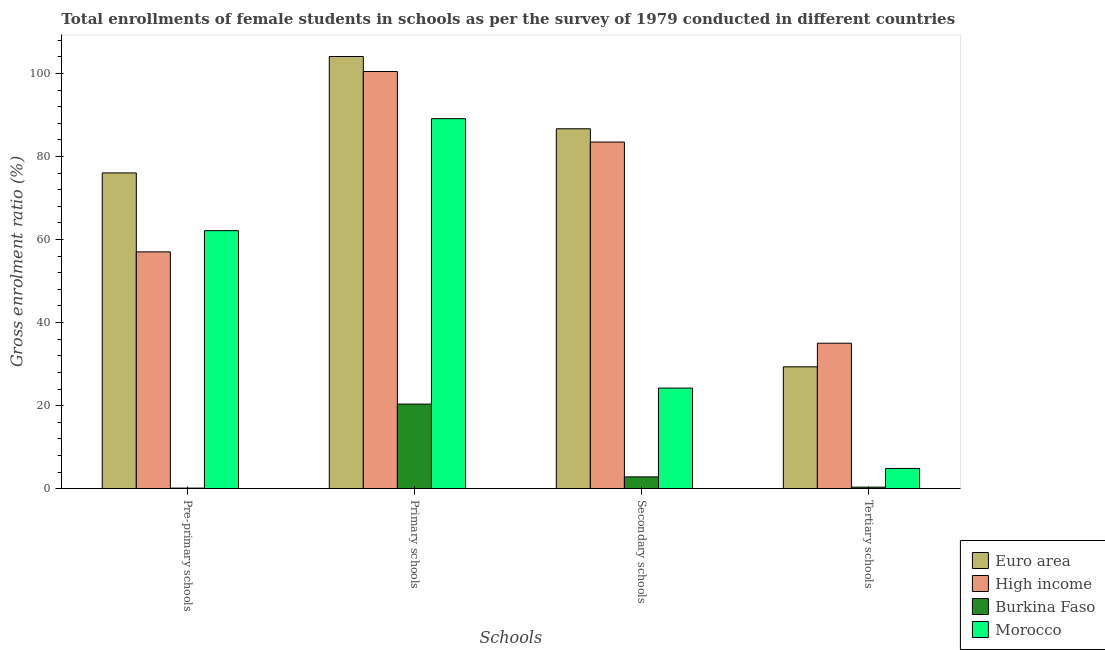How many different coloured bars are there?
Offer a terse response. 4. Are the number of bars per tick equal to the number of legend labels?
Provide a short and direct response. Yes. Are the number of bars on each tick of the X-axis equal?
Your answer should be compact. Yes. How many bars are there on the 4th tick from the left?
Your answer should be compact. 4. How many bars are there on the 1st tick from the right?
Ensure brevity in your answer.  4. What is the label of the 4th group of bars from the left?
Provide a short and direct response. Tertiary schools. What is the gross enrolment ratio(female) in pre-primary schools in Euro area?
Offer a terse response. 76.03. Across all countries, what is the maximum gross enrolment ratio(female) in primary schools?
Your answer should be compact. 104.08. Across all countries, what is the minimum gross enrolment ratio(female) in tertiary schools?
Your answer should be very brief. 0.37. In which country was the gross enrolment ratio(female) in primary schools minimum?
Give a very brief answer. Burkina Faso. What is the total gross enrolment ratio(female) in tertiary schools in the graph?
Your response must be concise. 69.61. What is the difference between the gross enrolment ratio(female) in primary schools in Burkina Faso and that in High income?
Ensure brevity in your answer.  -80.08. What is the difference between the gross enrolment ratio(female) in secondary schools in Morocco and the gross enrolment ratio(female) in tertiary schools in High income?
Your response must be concise. -10.81. What is the average gross enrolment ratio(female) in tertiary schools per country?
Keep it short and to the point. 17.4. What is the difference between the gross enrolment ratio(female) in tertiary schools and gross enrolment ratio(female) in secondary schools in Burkina Faso?
Your response must be concise. -2.47. What is the ratio of the gross enrolment ratio(female) in pre-primary schools in Burkina Faso to that in Morocco?
Keep it short and to the point. 0. Is the difference between the gross enrolment ratio(female) in pre-primary schools in High income and Euro area greater than the difference between the gross enrolment ratio(female) in secondary schools in High income and Euro area?
Make the answer very short. No. What is the difference between the highest and the second highest gross enrolment ratio(female) in tertiary schools?
Your answer should be compact. 5.68. What is the difference between the highest and the lowest gross enrolment ratio(female) in pre-primary schools?
Provide a succinct answer. 75.9. In how many countries, is the gross enrolment ratio(female) in secondary schools greater than the average gross enrolment ratio(female) in secondary schools taken over all countries?
Your answer should be very brief. 2. Is the sum of the gross enrolment ratio(female) in secondary schools in Burkina Faso and High income greater than the maximum gross enrolment ratio(female) in pre-primary schools across all countries?
Your answer should be very brief. Yes. Is it the case that in every country, the sum of the gross enrolment ratio(female) in tertiary schools and gross enrolment ratio(female) in pre-primary schools is greater than the sum of gross enrolment ratio(female) in primary schools and gross enrolment ratio(female) in secondary schools?
Your response must be concise. No. What does the 1st bar from the left in Tertiary schools represents?
Provide a succinct answer. Euro area. What does the 2nd bar from the right in Secondary schools represents?
Your answer should be very brief. Burkina Faso. How many bars are there?
Keep it short and to the point. 16. Are all the bars in the graph horizontal?
Ensure brevity in your answer.  No. How many countries are there in the graph?
Provide a short and direct response. 4. What is the difference between two consecutive major ticks on the Y-axis?
Your answer should be compact. 20. Does the graph contain any zero values?
Offer a terse response. No. Does the graph contain grids?
Your response must be concise. No. Where does the legend appear in the graph?
Offer a terse response. Bottom right. How many legend labels are there?
Provide a short and direct response. 4. How are the legend labels stacked?
Your answer should be compact. Vertical. What is the title of the graph?
Ensure brevity in your answer.  Total enrollments of female students in schools as per the survey of 1979 conducted in different countries. Does "Grenada" appear as one of the legend labels in the graph?
Offer a terse response. No. What is the label or title of the X-axis?
Ensure brevity in your answer.  Schools. What is the Gross enrolment ratio (%) of Euro area in Pre-primary schools?
Offer a very short reply. 76.03. What is the Gross enrolment ratio (%) of High income in Pre-primary schools?
Your response must be concise. 57.02. What is the Gross enrolment ratio (%) of Burkina Faso in Pre-primary schools?
Keep it short and to the point. 0.14. What is the Gross enrolment ratio (%) of Morocco in Pre-primary schools?
Your answer should be very brief. 62.14. What is the Gross enrolment ratio (%) in Euro area in Primary schools?
Ensure brevity in your answer.  104.08. What is the Gross enrolment ratio (%) in High income in Primary schools?
Provide a succinct answer. 100.45. What is the Gross enrolment ratio (%) in Burkina Faso in Primary schools?
Your answer should be compact. 20.37. What is the Gross enrolment ratio (%) in Morocco in Primary schools?
Ensure brevity in your answer.  89.1. What is the Gross enrolment ratio (%) of Euro area in Secondary schools?
Ensure brevity in your answer.  86.67. What is the Gross enrolment ratio (%) of High income in Secondary schools?
Your answer should be very brief. 83.47. What is the Gross enrolment ratio (%) of Burkina Faso in Secondary schools?
Provide a short and direct response. 2.84. What is the Gross enrolment ratio (%) in Morocco in Secondary schools?
Your response must be concise. 24.22. What is the Gross enrolment ratio (%) in Euro area in Tertiary schools?
Keep it short and to the point. 29.34. What is the Gross enrolment ratio (%) of High income in Tertiary schools?
Offer a very short reply. 35.03. What is the Gross enrolment ratio (%) of Burkina Faso in Tertiary schools?
Ensure brevity in your answer.  0.37. What is the Gross enrolment ratio (%) in Morocco in Tertiary schools?
Your response must be concise. 4.87. Across all Schools, what is the maximum Gross enrolment ratio (%) in Euro area?
Ensure brevity in your answer.  104.08. Across all Schools, what is the maximum Gross enrolment ratio (%) of High income?
Provide a short and direct response. 100.45. Across all Schools, what is the maximum Gross enrolment ratio (%) of Burkina Faso?
Provide a succinct answer. 20.37. Across all Schools, what is the maximum Gross enrolment ratio (%) of Morocco?
Keep it short and to the point. 89.1. Across all Schools, what is the minimum Gross enrolment ratio (%) of Euro area?
Make the answer very short. 29.34. Across all Schools, what is the minimum Gross enrolment ratio (%) of High income?
Ensure brevity in your answer.  35.03. Across all Schools, what is the minimum Gross enrolment ratio (%) in Burkina Faso?
Your answer should be compact. 0.14. Across all Schools, what is the minimum Gross enrolment ratio (%) in Morocco?
Your answer should be very brief. 4.87. What is the total Gross enrolment ratio (%) in Euro area in the graph?
Offer a very short reply. 296.12. What is the total Gross enrolment ratio (%) of High income in the graph?
Your response must be concise. 275.98. What is the total Gross enrolment ratio (%) of Burkina Faso in the graph?
Your response must be concise. 23.72. What is the total Gross enrolment ratio (%) of Morocco in the graph?
Ensure brevity in your answer.  180.33. What is the difference between the Gross enrolment ratio (%) of Euro area in Pre-primary schools and that in Primary schools?
Provide a short and direct response. -28.04. What is the difference between the Gross enrolment ratio (%) in High income in Pre-primary schools and that in Primary schools?
Keep it short and to the point. -43.43. What is the difference between the Gross enrolment ratio (%) in Burkina Faso in Pre-primary schools and that in Primary schools?
Keep it short and to the point. -20.23. What is the difference between the Gross enrolment ratio (%) in Morocco in Pre-primary schools and that in Primary schools?
Your answer should be compact. -26.96. What is the difference between the Gross enrolment ratio (%) in Euro area in Pre-primary schools and that in Secondary schools?
Your answer should be compact. -10.63. What is the difference between the Gross enrolment ratio (%) of High income in Pre-primary schools and that in Secondary schools?
Your response must be concise. -26.45. What is the difference between the Gross enrolment ratio (%) of Burkina Faso in Pre-primary schools and that in Secondary schools?
Keep it short and to the point. -2.7. What is the difference between the Gross enrolment ratio (%) in Morocco in Pre-primary schools and that in Secondary schools?
Keep it short and to the point. 37.91. What is the difference between the Gross enrolment ratio (%) of Euro area in Pre-primary schools and that in Tertiary schools?
Give a very brief answer. 46.69. What is the difference between the Gross enrolment ratio (%) of High income in Pre-primary schools and that in Tertiary schools?
Keep it short and to the point. 22. What is the difference between the Gross enrolment ratio (%) of Burkina Faso in Pre-primary schools and that in Tertiary schools?
Your answer should be very brief. -0.23. What is the difference between the Gross enrolment ratio (%) in Morocco in Pre-primary schools and that in Tertiary schools?
Keep it short and to the point. 57.27. What is the difference between the Gross enrolment ratio (%) of Euro area in Primary schools and that in Secondary schools?
Your response must be concise. 17.41. What is the difference between the Gross enrolment ratio (%) of High income in Primary schools and that in Secondary schools?
Offer a very short reply. 16.98. What is the difference between the Gross enrolment ratio (%) in Burkina Faso in Primary schools and that in Secondary schools?
Make the answer very short. 17.53. What is the difference between the Gross enrolment ratio (%) of Morocco in Primary schools and that in Secondary schools?
Your answer should be compact. 64.88. What is the difference between the Gross enrolment ratio (%) in Euro area in Primary schools and that in Tertiary schools?
Offer a very short reply. 74.73. What is the difference between the Gross enrolment ratio (%) of High income in Primary schools and that in Tertiary schools?
Keep it short and to the point. 65.43. What is the difference between the Gross enrolment ratio (%) of Burkina Faso in Primary schools and that in Tertiary schools?
Provide a succinct answer. 20. What is the difference between the Gross enrolment ratio (%) of Morocco in Primary schools and that in Tertiary schools?
Keep it short and to the point. 84.23. What is the difference between the Gross enrolment ratio (%) in Euro area in Secondary schools and that in Tertiary schools?
Provide a short and direct response. 57.32. What is the difference between the Gross enrolment ratio (%) of High income in Secondary schools and that in Tertiary schools?
Ensure brevity in your answer.  48.44. What is the difference between the Gross enrolment ratio (%) in Burkina Faso in Secondary schools and that in Tertiary schools?
Provide a short and direct response. 2.47. What is the difference between the Gross enrolment ratio (%) in Morocco in Secondary schools and that in Tertiary schools?
Your answer should be compact. 19.35. What is the difference between the Gross enrolment ratio (%) of Euro area in Pre-primary schools and the Gross enrolment ratio (%) of High income in Primary schools?
Provide a short and direct response. -24.42. What is the difference between the Gross enrolment ratio (%) in Euro area in Pre-primary schools and the Gross enrolment ratio (%) in Burkina Faso in Primary schools?
Make the answer very short. 55.66. What is the difference between the Gross enrolment ratio (%) of Euro area in Pre-primary schools and the Gross enrolment ratio (%) of Morocco in Primary schools?
Give a very brief answer. -13.07. What is the difference between the Gross enrolment ratio (%) of High income in Pre-primary schools and the Gross enrolment ratio (%) of Burkina Faso in Primary schools?
Give a very brief answer. 36.65. What is the difference between the Gross enrolment ratio (%) of High income in Pre-primary schools and the Gross enrolment ratio (%) of Morocco in Primary schools?
Your answer should be compact. -32.08. What is the difference between the Gross enrolment ratio (%) of Burkina Faso in Pre-primary schools and the Gross enrolment ratio (%) of Morocco in Primary schools?
Your answer should be very brief. -88.96. What is the difference between the Gross enrolment ratio (%) in Euro area in Pre-primary schools and the Gross enrolment ratio (%) in High income in Secondary schools?
Provide a succinct answer. -7.44. What is the difference between the Gross enrolment ratio (%) of Euro area in Pre-primary schools and the Gross enrolment ratio (%) of Burkina Faso in Secondary schools?
Make the answer very short. 73.19. What is the difference between the Gross enrolment ratio (%) of Euro area in Pre-primary schools and the Gross enrolment ratio (%) of Morocco in Secondary schools?
Give a very brief answer. 51.81. What is the difference between the Gross enrolment ratio (%) of High income in Pre-primary schools and the Gross enrolment ratio (%) of Burkina Faso in Secondary schools?
Keep it short and to the point. 54.18. What is the difference between the Gross enrolment ratio (%) in High income in Pre-primary schools and the Gross enrolment ratio (%) in Morocco in Secondary schools?
Ensure brevity in your answer.  32.8. What is the difference between the Gross enrolment ratio (%) in Burkina Faso in Pre-primary schools and the Gross enrolment ratio (%) in Morocco in Secondary schools?
Keep it short and to the point. -24.09. What is the difference between the Gross enrolment ratio (%) of Euro area in Pre-primary schools and the Gross enrolment ratio (%) of High income in Tertiary schools?
Your response must be concise. 41.01. What is the difference between the Gross enrolment ratio (%) of Euro area in Pre-primary schools and the Gross enrolment ratio (%) of Burkina Faso in Tertiary schools?
Offer a very short reply. 75.67. What is the difference between the Gross enrolment ratio (%) in Euro area in Pre-primary schools and the Gross enrolment ratio (%) in Morocco in Tertiary schools?
Your answer should be compact. 71.16. What is the difference between the Gross enrolment ratio (%) of High income in Pre-primary schools and the Gross enrolment ratio (%) of Burkina Faso in Tertiary schools?
Your answer should be very brief. 56.66. What is the difference between the Gross enrolment ratio (%) in High income in Pre-primary schools and the Gross enrolment ratio (%) in Morocco in Tertiary schools?
Your answer should be very brief. 52.15. What is the difference between the Gross enrolment ratio (%) of Burkina Faso in Pre-primary schools and the Gross enrolment ratio (%) of Morocco in Tertiary schools?
Your response must be concise. -4.73. What is the difference between the Gross enrolment ratio (%) in Euro area in Primary schools and the Gross enrolment ratio (%) in High income in Secondary schools?
Your answer should be compact. 20.6. What is the difference between the Gross enrolment ratio (%) of Euro area in Primary schools and the Gross enrolment ratio (%) of Burkina Faso in Secondary schools?
Provide a succinct answer. 101.23. What is the difference between the Gross enrolment ratio (%) of Euro area in Primary schools and the Gross enrolment ratio (%) of Morocco in Secondary schools?
Keep it short and to the point. 79.85. What is the difference between the Gross enrolment ratio (%) of High income in Primary schools and the Gross enrolment ratio (%) of Burkina Faso in Secondary schools?
Ensure brevity in your answer.  97.61. What is the difference between the Gross enrolment ratio (%) in High income in Primary schools and the Gross enrolment ratio (%) in Morocco in Secondary schools?
Provide a succinct answer. 76.23. What is the difference between the Gross enrolment ratio (%) in Burkina Faso in Primary schools and the Gross enrolment ratio (%) in Morocco in Secondary schools?
Provide a short and direct response. -3.85. What is the difference between the Gross enrolment ratio (%) in Euro area in Primary schools and the Gross enrolment ratio (%) in High income in Tertiary schools?
Your response must be concise. 69.05. What is the difference between the Gross enrolment ratio (%) of Euro area in Primary schools and the Gross enrolment ratio (%) of Burkina Faso in Tertiary schools?
Your response must be concise. 103.71. What is the difference between the Gross enrolment ratio (%) in Euro area in Primary schools and the Gross enrolment ratio (%) in Morocco in Tertiary schools?
Your answer should be compact. 99.2. What is the difference between the Gross enrolment ratio (%) in High income in Primary schools and the Gross enrolment ratio (%) in Burkina Faso in Tertiary schools?
Your answer should be compact. 100.08. What is the difference between the Gross enrolment ratio (%) in High income in Primary schools and the Gross enrolment ratio (%) in Morocco in Tertiary schools?
Give a very brief answer. 95.58. What is the difference between the Gross enrolment ratio (%) of Burkina Faso in Primary schools and the Gross enrolment ratio (%) of Morocco in Tertiary schools?
Keep it short and to the point. 15.5. What is the difference between the Gross enrolment ratio (%) of Euro area in Secondary schools and the Gross enrolment ratio (%) of High income in Tertiary schools?
Your response must be concise. 51.64. What is the difference between the Gross enrolment ratio (%) of Euro area in Secondary schools and the Gross enrolment ratio (%) of Burkina Faso in Tertiary schools?
Offer a very short reply. 86.3. What is the difference between the Gross enrolment ratio (%) of Euro area in Secondary schools and the Gross enrolment ratio (%) of Morocco in Tertiary schools?
Keep it short and to the point. 81.8. What is the difference between the Gross enrolment ratio (%) in High income in Secondary schools and the Gross enrolment ratio (%) in Burkina Faso in Tertiary schools?
Provide a succinct answer. 83.1. What is the difference between the Gross enrolment ratio (%) in High income in Secondary schools and the Gross enrolment ratio (%) in Morocco in Tertiary schools?
Ensure brevity in your answer.  78.6. What is the difference between the Gross enrolment ratio (%) in Burkina Faso in Secondary schools and the Gross enrolment ratio (%) in Morocco in Tertiary schools?
Offer a terse response. -2.03. What is the average Gross enrolment ratio (%) of Euro area per Schools?
Keep it short and to the point. 74.03. What is the average Gross enrolment ratio (%) in High income per Schools?
Offer a terse response. 68.99. What is the average Gross enrolment ratio (%) in Burkina Faso per Schools?
Offer a very short reply. 5.93. What is the average Gross enrolment ratio (%) of Morocco per Schools?
Give a very brief answer. 45.08. What is the difference between the Gross enrolment ratio (%) in Euro area and Gross enrolment ratio (%) in High income in Pre-primary schools?
Offer a terse response. 19.01. What is the difference between the Gross enrolment ratio (%) in Euro area and Gross enrolment ratio (%) in Burkina Faso in Pre-primary schools?
Your answer should be very brief. 75.9. What is the difference between the Gross enrolment ratio (%) of Euro area and Gross enrolment ratio (%) of Morocco in Pre-primary schools?
Keep it short and to the point. 13.9. What is the difference between the Gross enrolment ratio (%) in High income and Gross enrolment ratio (%) in Burkina Faso in Pre-primary schools?
Keep it short and to the point. 56.89. What is the difference between the Gross enrolment ratio (%) of High income and Gross enrolment ratio (%) of Morocco in Pre-primary schools?
Provide a succinct answer. -5.11. What is the difference between the Gross enrolment ratio (%) of Burkina Faso and Gross enrolment ratio (%) of Morocco in Pre-primary schools?
Ensure brevity in your answer.  -62. What is the difference between the Gross enrolment ratio (%) in Euro area and Gross enrolment ratio (%) in High income in Primary schools?
Your response must be concise. 3.62. What is the difference between the Gross enrolment ratio (%) of Euro area and Gross enrolment ratio (%) of Burkina Faso in Primary schools?
Give a very brief answer. 83.7. What is the difference between the Gross enrolment ratio (%) of Euro area and Gross enrolment ratio (%) of Morocco in Primary schools?
Offer a very short reply. 14.97. What is the difference between the Gross enrolment ratio (%) of High income and Gross enrolment ratio (%) of Burkina Faso in Primary schools?
Offer a terse response. 80.08. What is the difference between the Gross enrolment ratio (%) in High income and Gross enrolment ratio (%) in Morocco in Primary schools?
Your answer should be compact. 11.35. What is the difference between the Gross enrolment ratio (%) of Burkina Faso and Gross enrolment ratio (%) of Morocco in Primary schools?
Keep it short and to the point. -68.73. What is the difference between the Gross enrolment ratio (%) of Euro area and Gross enrolment ratio (%) of High income in Secondary schools?
Keep it short and to the point. 3.2. What is the difference between the Gross enrolment ratio (%) in Euro area and Gross enrolment ratio (%) in Burkina Faso in Secondary schools?
Your answer should be very brief. 83.83. What is the difference between the Gross enrolment ratio (%) of Euro area and Gross enrolment ratio (%) of Morocco in Secondary schools?
Your answer should be compact. 62.45. What is the difference between the Gross enrolment ratio (%) of High income and Gross enrolment ratio (%) of Burkina Faso in Secondary schools?
Keep it short and to the point. 80.63. What is the difference between the Gross enrolment ratio (%) in High income and Gross enrolment ratio (%) in Morocco in Secondary schools?
Ensure brevity in your answer.  59.25. What is the difference between the Gross enrolment ratio (%) in Burkina Faso and Gross enrolment ratio (%) in Morocco in Secondary schools?
Keep it short and to the point. -21.38. What is the difference between the Gross enrolment ratio (%) of Euro area and Gross enrolment ratio (%) of High income in Tertiary schools?
Give a very brief answer. -5.68. What is the difference between the Gross enrolment ratio (%) of Euro area and Gross enrolment ratio (%) of Burkina Faso in Tertiary schools?
Provide a short and direct response. 28.98. What is the difference between the Gross enrolment ratio (%) of Euro area and Gross enrolment ratio (%) of Morocco in Tertiary schools?
Make the answer very short. 24.47. What is the difference between the Gross enrolment ratio (%) in High income and Gross enrolment ratio (%) in Burkina Faso in Tertiary schools?
Offer a very short reply. 34.66. What is the difference between the Gross enrolment ratio (%) of High income and Gross enrolment ratio (%) of Morocco in Tertiary schools?
Your answer should be very brief. 30.16. What is the difference between the Gross enrolment ratio (%) of Burkina Faso and Gross enrolment ratio (%) of Morocco in Tertiary schools?
Your answer should be very brief. -4.5. What is the ratio of the Gross enrolment ratio (%) of Euro area in Pre-primary schools to that in Primary schools?
Offer a very short reply. 0.73. What is the ratio of the Gross enrolment ratio (%) in High income in Pre-primary schools to that in Primary schools?
Make the answer very short. 0.57. What is the ratio of the Gross enrolment ratio (%) of Burkina Faso in Pre-primary schools to that in Primary schools?
Make the answer very short. 0.01. What is the ratio of the Gross enrolment ratio (%) of Morocco in Pre-primary schools to that in Primary schools?
Your response must be concise. 0.7. What is the ratio of the Gross enrolment ratio (%) of Euro area in Pre-primary schools to that in Secondary schools?
Provide a succinct answer. 0.88. What is the ratio of the Gross enrolment ratio (%) of High income in Pre-primary schools to that in Secondary schools?
Your answer should be very brief. 0.68. What is the ratio of the Gross enrolment ratio (%) of Burkina Faso in Pre-primary schools to that in Secondary schools?
Your answer should be compact. 0.05. What is the ratio of the Gross enrolment ratio (%) in Morocco in Pre-primary schools to that in Secondary schools?
Provide a succinct answer. 2.57. What is the ratio of the Gross enrolment ratio (%) of Euro area in Pre-primary schools to that in Tertiary schools?
Make the answer very short. 2.59. What is the ratio of the Gross enrolment ratio (%) of High income in Pre-primary schools to that in Tertiary schools?
Your answer should be very brief. 1.63. What is the ratio of the Gross enrolment ratio (%) of Burkina Faso in Pre-primary schools to that in Tertiary schools?
Give a very brief answer. 0.37. What is the ratio of the Gross enrolment ratio (%) of Morocco in Pre-primary schools to that in Tertiary schools?
Provide a short and direct response. 12.76. What is the ratio of the Gross enrolment ratio (%) of Euro area in Primary schools to that in Secondary schools?
Keep it short and to the point. 1.2. What is the ratio of the Gross enrolment ratio (%) in High income in Primary schools to that in Secondary schools?
Ensure brevity in your answer.  1.2. What is the ratio of the Gross enrolment ratio (%) in Burkina Faso in Primary schools to that in Secondary schools?
Your response must be concise. 7.17. What is the ratio of the Gross enrolment ratio (%) of Morocco in Primary schools to that in Secondary schools?
Your response must be concise. 3.68. What is the ratio of the Gross enrolment ratio (%) in Euro area in Primary schools to that in Tertiary schools?
Make the answer very short. 3.55. What is the ratio of the Gross enrolment ratio (%) of High income in Primary schools to that in Tertiary schools?
Provide a short and direct response. 2.87. What is the ratio of the Gross enrolment ratio (%) in Burkina Faso in Primary schools to that in Tertiary schools?
Provide a short and direct response. 55.21. What is the ratio of the Gross enrolment ratio (%) of Morocco in Primary schools to that in Tertiary schools?
Offer a terse response. 18.29. What is the ratio of the Gross enrolment ratio (%) of Euro area in Secondary schools to that in Tertiary schools?
Provide a short and direct response. 2.95. What is the ratio of the Gross enrolment ratio (%) of High income in Secondary schools to that in Tertiary schools?
Provide a short and direct response. 2.38. What is the ratio of the Gross enrolment ratio (%) of Burkina Faso in Secondary schools to that in Tertiary schools?
Your answer should be compact. 7.7. What is the ratio of the Gross enrolment ratio (%) in Morocco in Secondary schools to that in Tertiary schools?
Make the answer very short. 4.97. What is the difference between the highest and the second highest Gross enrolment ratio (%) in Euro area?
Your response must be concise. 17.41. What is the difference between the highest and the second highest Gross enrolment ratio (%) of High income?
Provide a succinct answer. 16.98. What is the difference between the highest and the second highest Gross enrolment ratio (%) of Burkina Faso?
Give a very brief answer. 17.53. What is the difference between the highest and the second highest Gross enrolment ratio (%) of Morocco?
Offer a terse response. 26.96. What is the difference between the highest and the lowest Gross enrolment ratio (%) of Euro area?
Your response must be concise. 74.73. What is the difference between the highest and the lowest Gross enrolment ratio (%) of High income?
Your response must be concise. 65.43. What is the difference between the highest and the lowest Gross enrolment ratio (%) of Burkina Faso?
Ensure brevity in your answer.  20.23. What is the difference between the highest and the lowest Gross enrolment ratio (%) of Morocco?
Your answer should be compact. 84.23. 